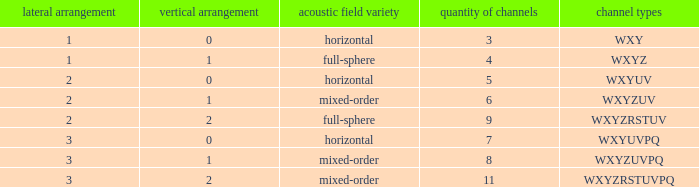If the channels is wxyzuv, what is the number of channels? 6.0. 